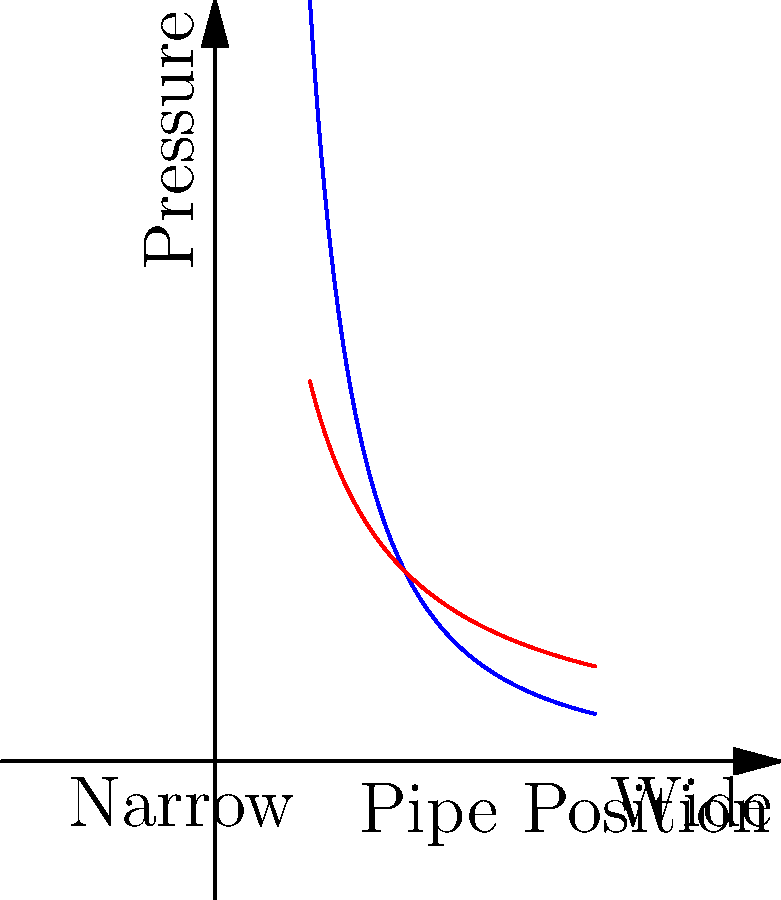As a small business owner dealing with software compatibility issues, you're exploring fluid dynamics simulation software. To test your understanding, consider a pipe with varying diameter. How does the pressure distribution change as the pipe narrows compared to when it widens? Refer to the graph, where the blue curve represents pressure in a narrowing pipe and the red curve represents pressure in a widening pipe. To understand the pressure distribution in a pipe with varying diameter, let's break it down step-by-step:

1. Bernoulli's principle: In fluid dynamics, Bernoulli's principle states that an increase in the speed of a fluid occurs simultaneously with a decrease in pressure or a decrease in the fluid's potential energy.

2. Continuity equation: The volumetric flow rate (Q) remains constant throughout the pipe. Q = A * v, where A is the cross-sectional area and v is the velocity.

3. Narrowing pipe (blue curve):
   - As the pipe narrows, A decreases.
   - To maintain constant Q, v must increase.
   - According to Bernoulli's principle, as v increases, pressure (P) must decrease.
   - This results in a steep decrease in pressure as the pipe narrows.

4. Widening pipe (red curve):
   - As the pipe widens, A increases.
   - To maintain constant Q, v must decrease.
   - According to Bernoulli's principle, as v decreases, P must increase.
   - This results in a gradual increase in pressure as the pipe widens.

5. Comparing the curves:
   - The blue curve (narrowing pipe) shows a more rapid change in pressure.
   - The red curve (widening pipe) shows a more gradual change in pressure.

This difference in pressure distribution is crucial for understanding fluid behavior in various pipe configurations, which is essential for many engineering applications, including the software you're considering for your business.
Answer: Pressure decreases more rapidly in narrowing pipes compared to the gradual increase in widening pipes. 